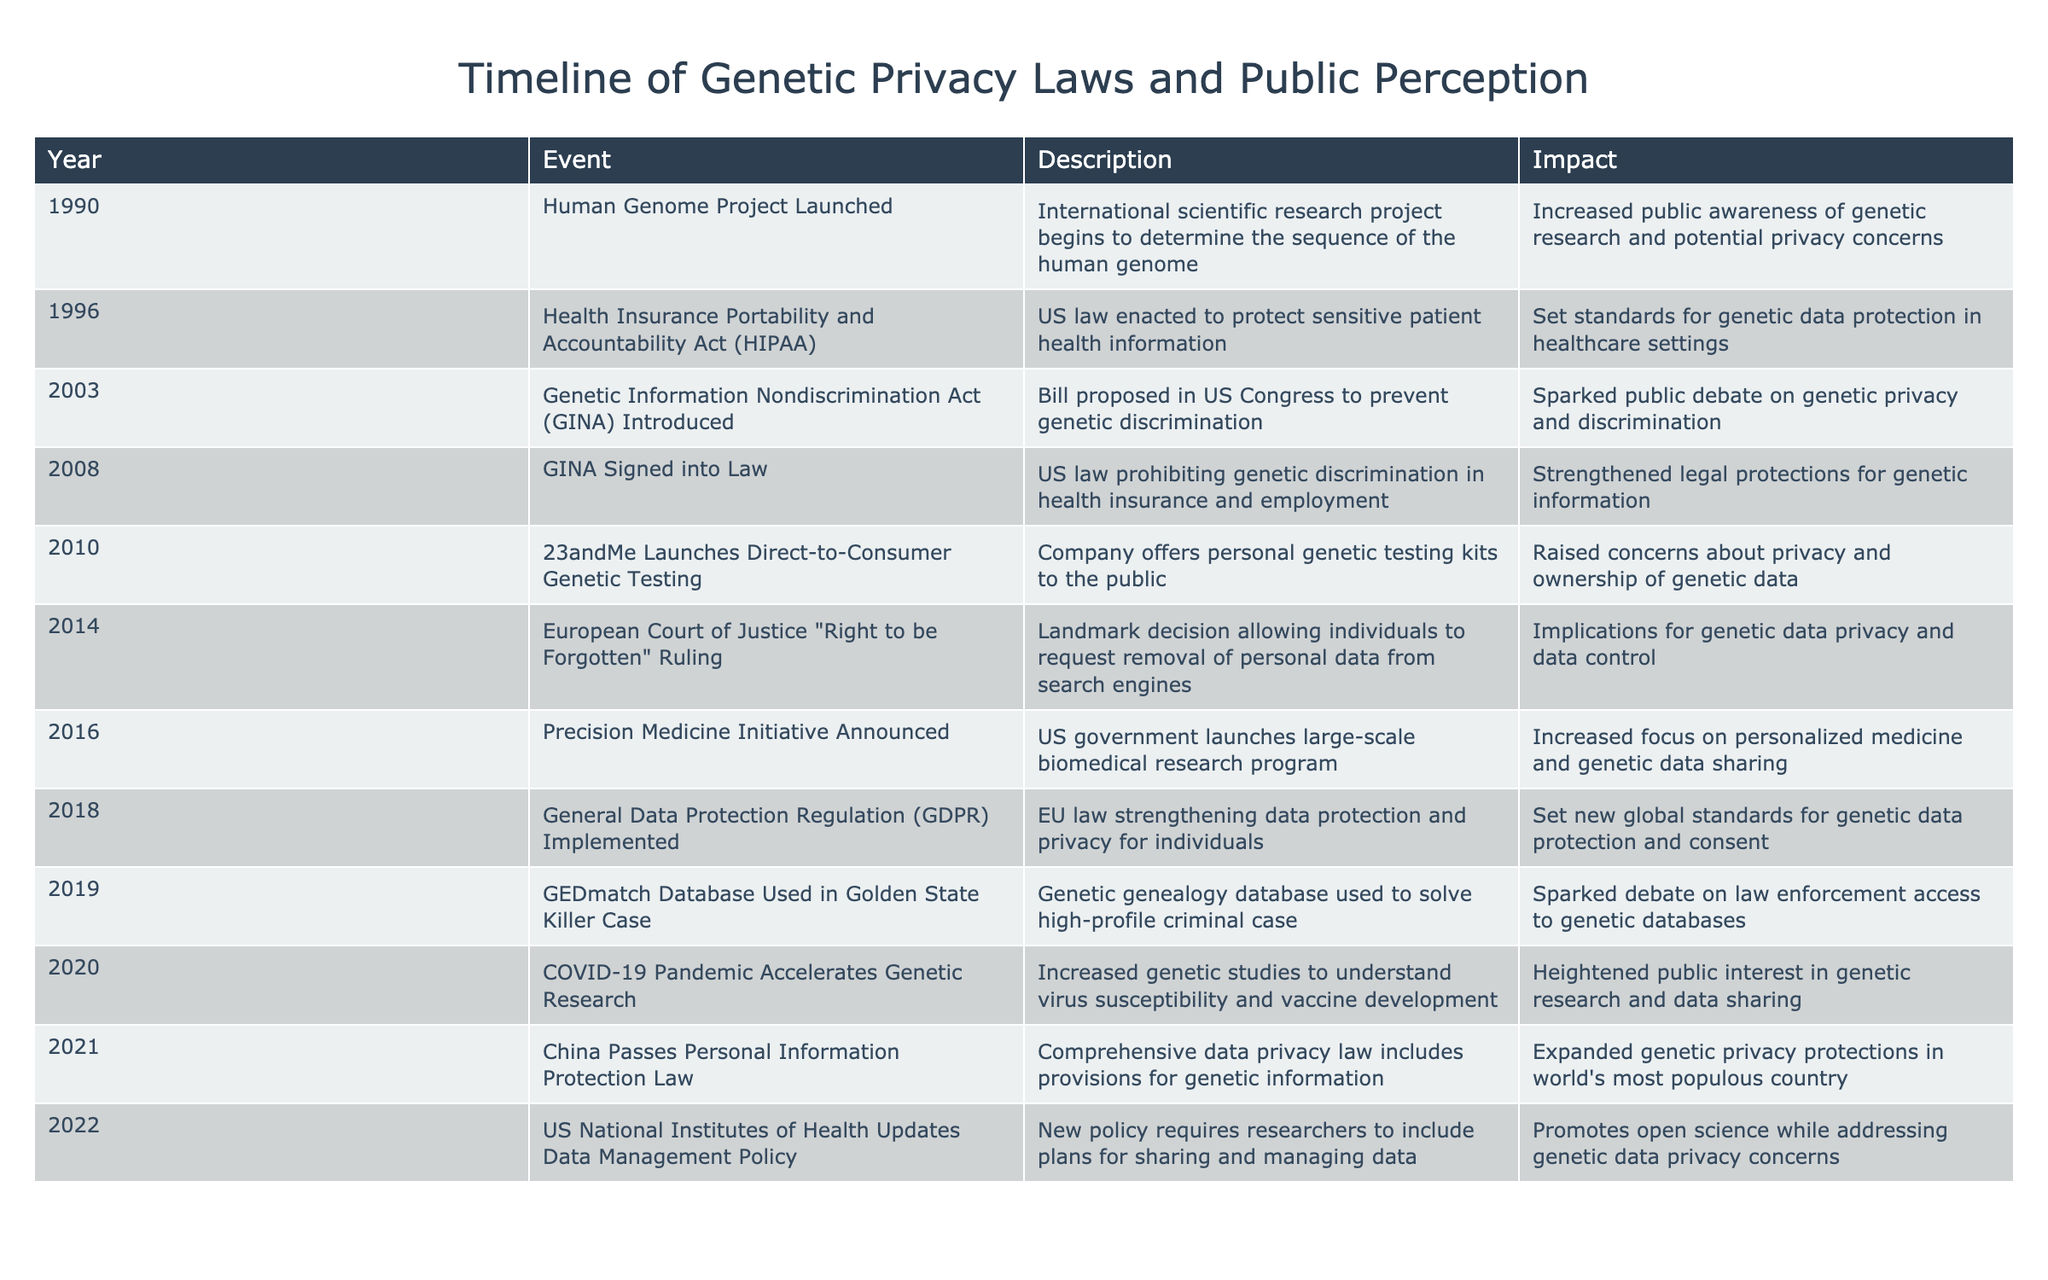What year was the Genetic Information Nondiscrimination Act introduced? The table indicates that the Genetic Information Nondiscrimination Act was introduced in the year 2003.
Answer: 2003 What significant event regarding genetic data privacy occurred in 2018? The table shows that in 2018, the General Data Protection Regulation was implemented, which strengthened data protection and privacy for individuals, setting new global standards for genetic data protection.
Answer: General Data Protection Regulation implemented Was the Human Genome Project launched before or after the introduction of HIPAA? According to the table, the Human Genome Project was launched in 1990 and HIPAA was enacted in 1996. Since 1990 is before 1996, the project was launched before HIPAA.
Answer: Before How many years passed between the launch of 23andMe and the signing of GINA into law? The table indicates that 23andMe was launched in 2010 and GINA was signed into law in 2008. The difference is 2010 - 2008 = 2 years.
Answer: 2 years Did the COVID-19 pandemic increase public interest in genetic research? The table states that the COVID-19 pandemic accelerated genetic research in 2020, raising public interest in genetic research and data sharing due to increased studies about virus susceptibility. Therefore, this statement is true.
Answer: Yes What was the impact of the GEDmatch database being used in the Golden State Killer case in 2019? The use of the GEDmatch database in this high-profile criminal case sparked a debate regarding law enforcement access to genetic databases, highlighting privacy issues and public perception concerns about such usages.
Answer: Sparked debate on law enforcement access Which event had the most impact on genetic data protection in healthcare? The Health Insurance Portability and Accountability Act (HIPAA) enacted in 1996 is noted in the table as setting standards for genetic data protection in healthcare settings, marking it as a significant event in this regard.
Answer: HIPAA enactment How many events listed in the table occurred after 2016? Referring to the table, the events after 2016 include the implementation of GDPR in 2018, the use of GEDmatch in 2019, the acceleration of genetic research due to the pandemic in 2020, the passing of China's law in 2021, and the NIH updating its policy in 2022. This totals 5 events.
Answer: 5 events 